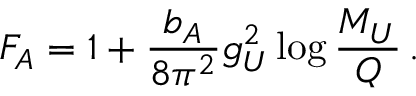<formula> <loc_0><loc_0><loc_500><loc_500>F _ { A } = 1 + \frac { b _ { A } } { 8 \pi ^ { 2 } } g _ { U } ^ { 2 } \log \frac { M _ { U } } { Q } \, .</formula> 